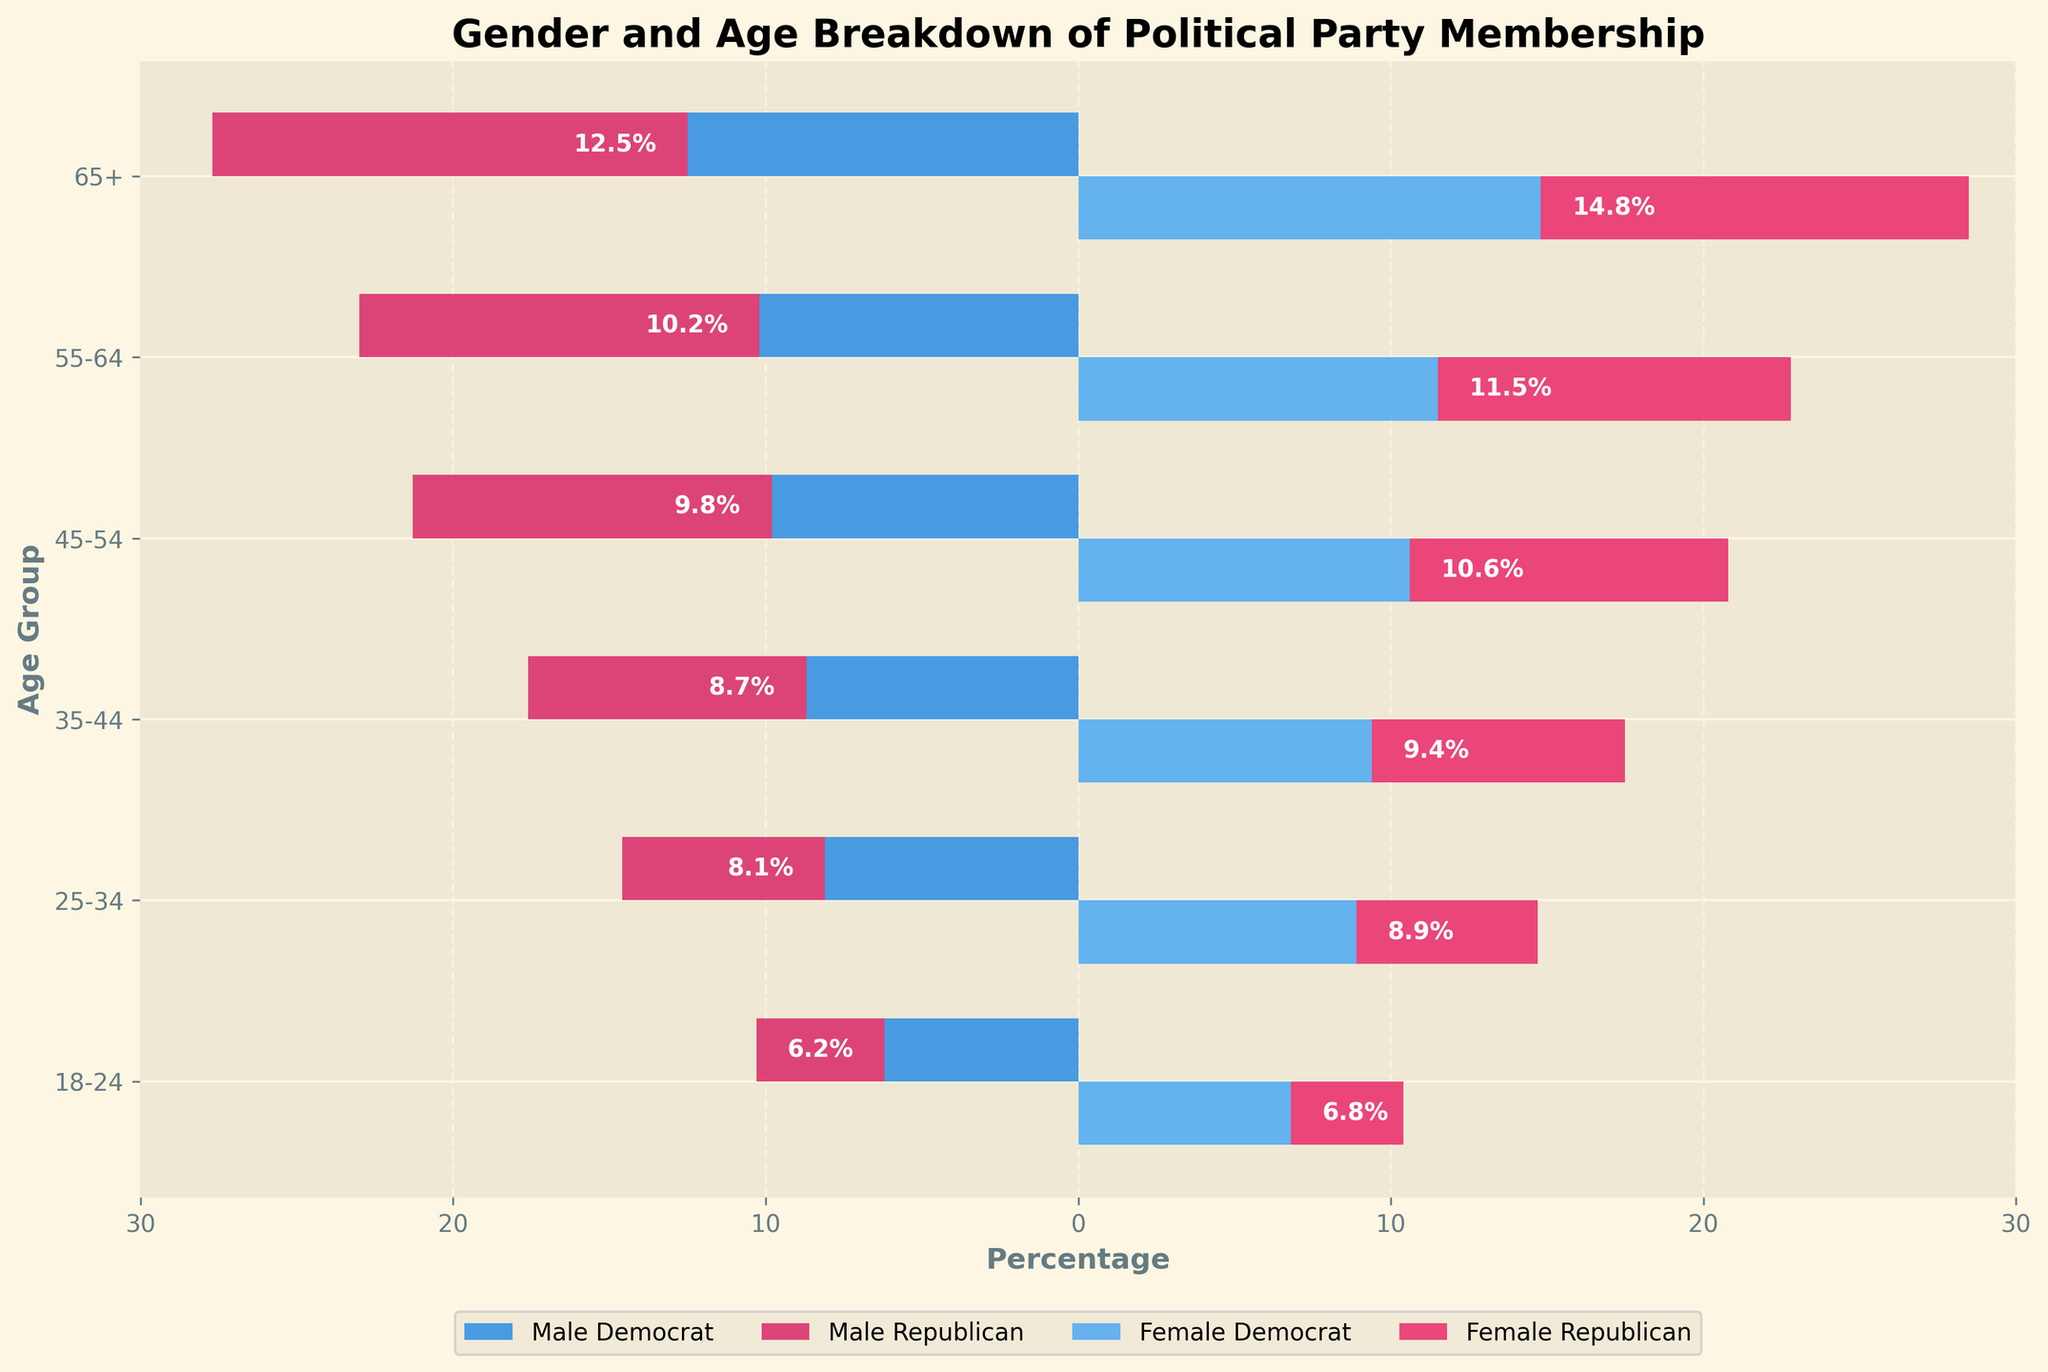Which age group has the highest percentage of male Republicans? We look at the bars corresponding to male Republicans for each age group; the 65+ age group has the highest value.
Answer: 65+ What percentage of female Democrats are in the 45-54 age group? Find the bar representing female Democrats in the 45-54 age group, which is 10.6.
Answer: 10.6% What's the combined percentage of male and female Republicans in the 25-34 age group? Sum the values for male and female Republicans in the 25-34 age group: 6.5 + 5.8 = 12.3.
Answer: 12.3% How does the percentage of male Democrats in the 18-24 age group compare to female Republicans in the same age group? Compare the bars for male Democrats and female Republicans in the 18-24 age group; 6.2 vs 3.6.
Answer: Higher Which party has a more balanced gender representation in the 55-64 age group? Compare the percentages of male and female members for both Democrats (10.2 and 11.5) and Republicans (12.8 and 11.3) in the 55-64 age group. Democrats are more balanced.
Answer: Democrats What's the total percentage of Democrats in the 35-44 age group? Sum the percentages of male and female Democrats in the 35-44 age group: 8.7 + 9.4.
Answer: 18.1% Is there any age group where female Democrats have a higher percentage than male Republicans? Check each age group; Female Democrats have a higher percentage than male Republicans in the 18-24 (6.8 vs. 4.1), 25-34 (8.9 vs. 6.5), and 35-44 (9.4 vs. 8.9) age groups.
Answer: Yes Which gender in the 65+ age group has the highest representation across both parties? Compare male Democrats (12.5), female Democrats (14.8), male Republicans (15.2), and female Republicans (13.7); male Republicans have the highest representation.
Answer: Male Republicans 